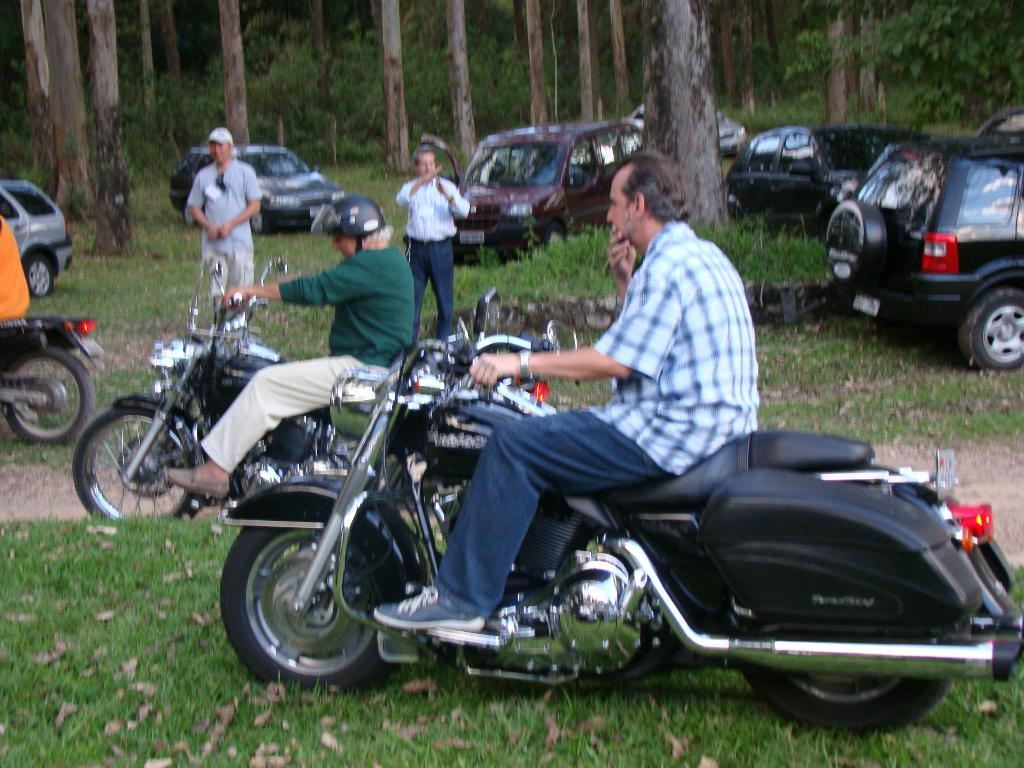How many people are on the bike in the image? There are three persons sitting on a bike in the image. What are the other people in the image doing? There are two other persons standing beside the bike. What can be seen in the background of the image? There are trees and cars in the background of the image. How many minutes does the chicken take to sharpen the pencil in the image? There is no chicken or pencil present in the image, so this question cannot be answered. 